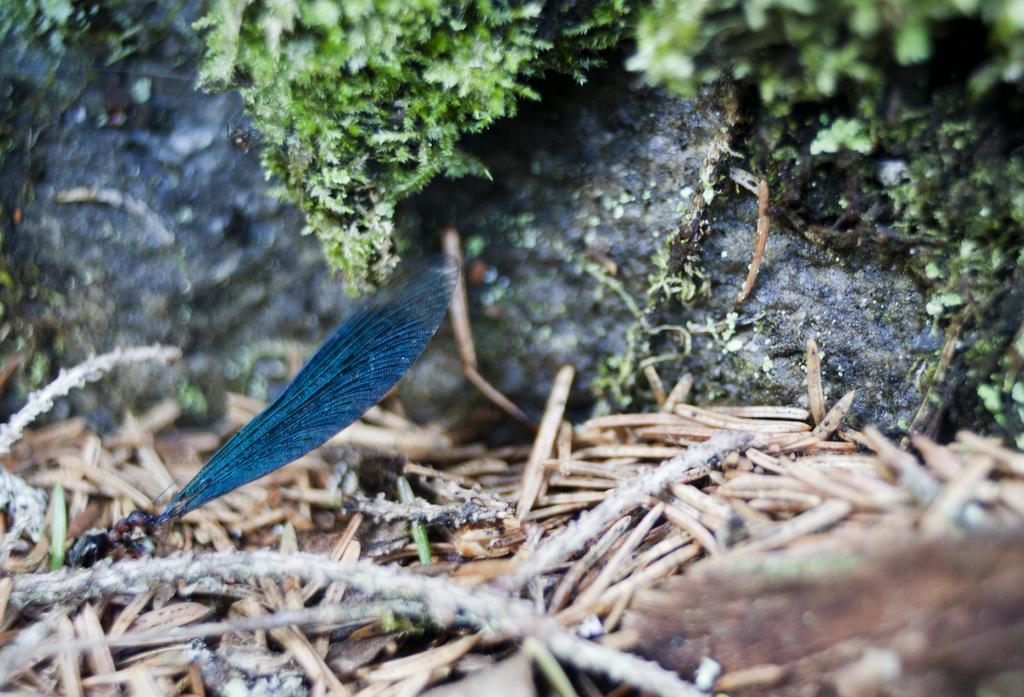Describe this image in one or two sentences. In this image we can see an insect on a stem. In the back there is rock with moses. Also we can see few other things on the ground. 